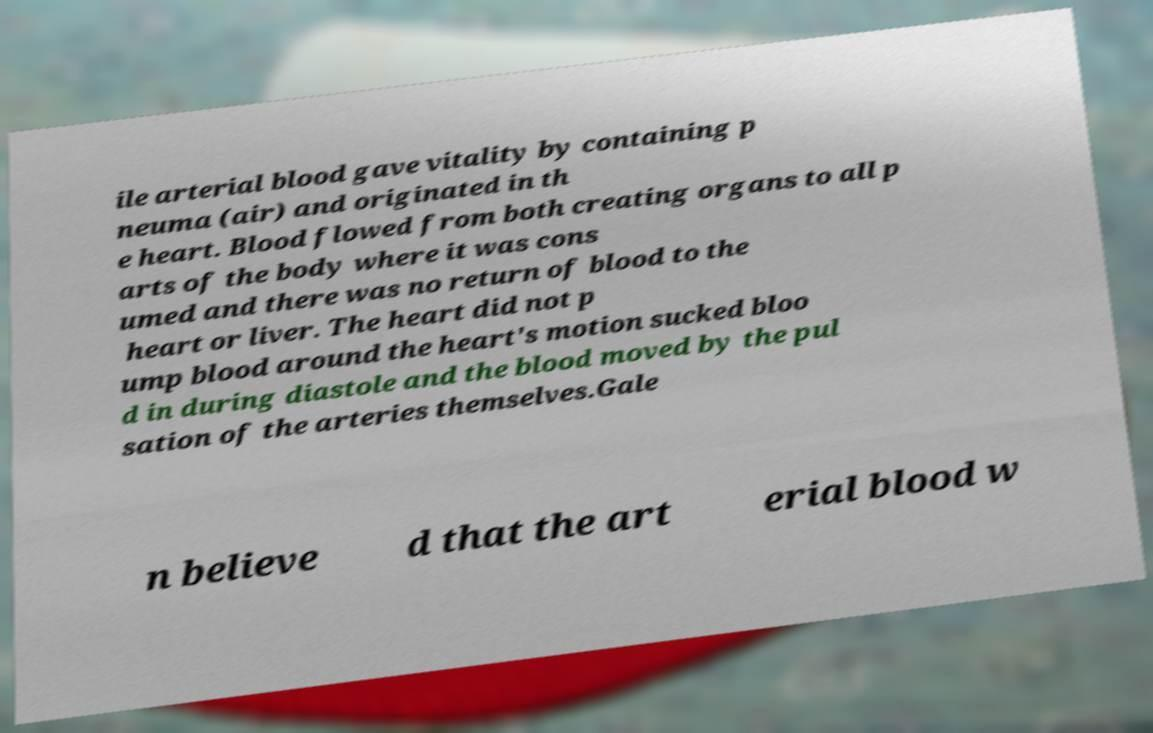Please read and relay the text visible in this image. What does it say? ile arterial blood gave vitality by containing p neuma (air) and originated in th e heart. Blood flowed from both creating organs to all p arts of the body where it was cons umed and there was no return of blood to the heart or liver. The heart did not p ump blood around the heart's motion sucked bloo d in during diastole and the blood moved by the pul sation of the arteries themselves.Gale n believe d that the art erial blood w 